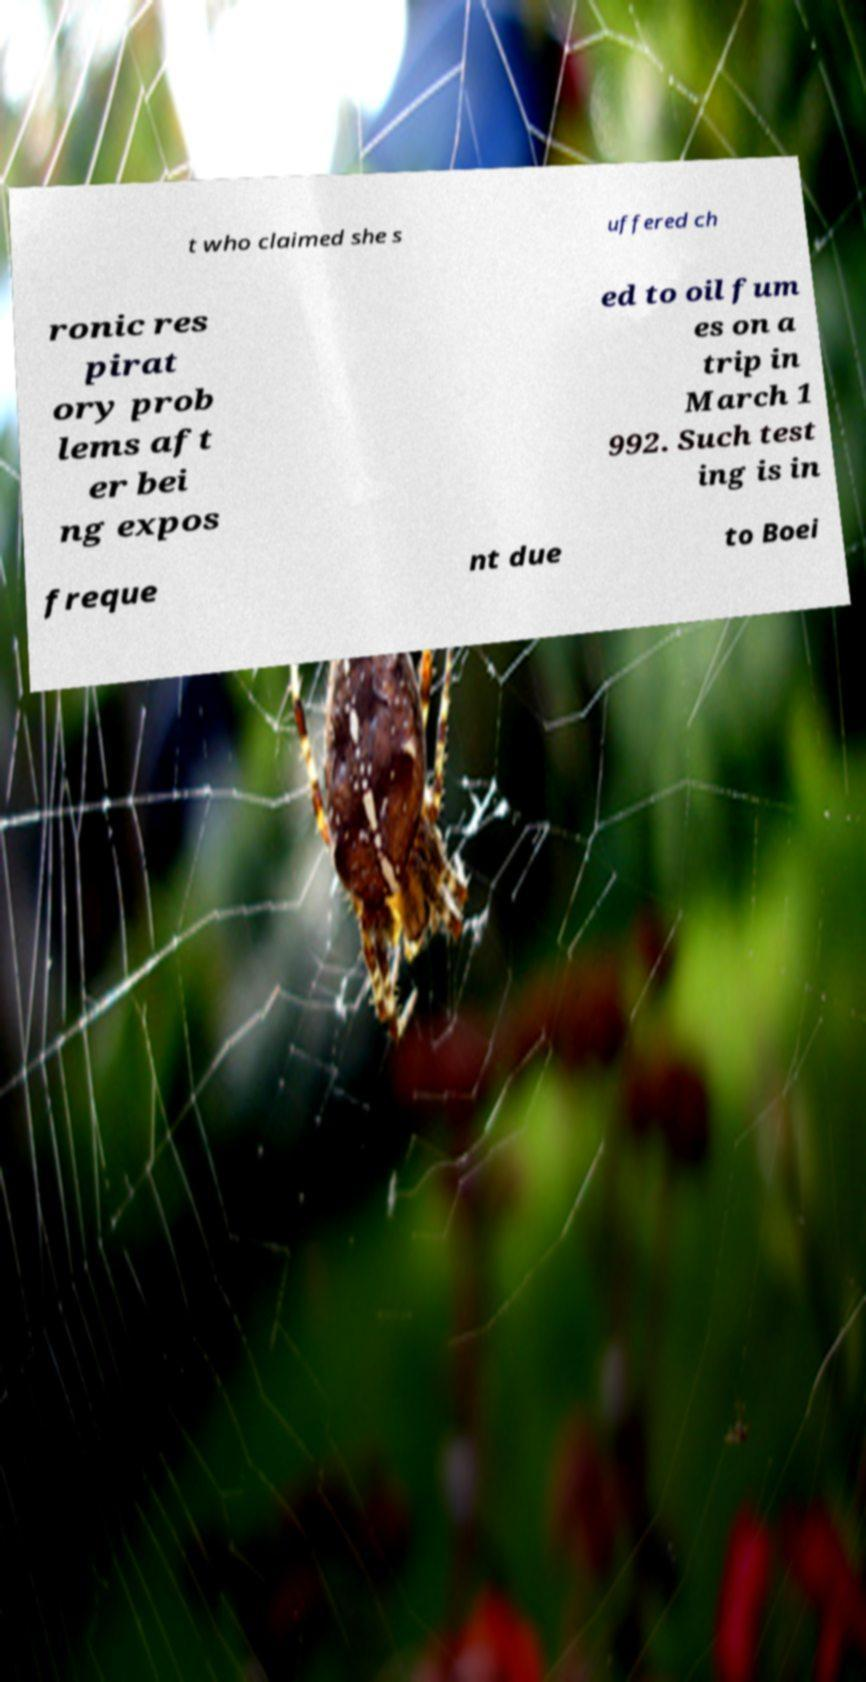Could you extract and type out the text from this image? t who claimed she s uffered ch ronic res pirat ory prob lems aft er bei ng expos ed to oil fum es on a trip in March 1 992. Such test ing is in freque nt due to Boei 